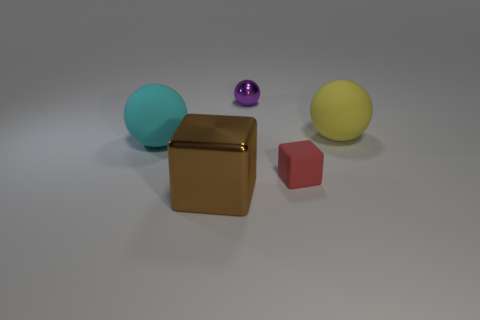Subtract all small purple spheres. How many spheres are left? 2 Add 2 small red matte objects. How many objects exist? 7 Subtract all yellow balls. How many balls are left? 2 Subtract all spheres. How many objects are left? 2 Subtract all yellow blocks. Subtract all red cylinders. How many blocks are left? 2 Subtract all shiny spheres. Subtract all big objects. How many objects are left? 1 Add 3 small shiny things. How many small shiny things are left? 4 Add 1 purple rubber balls. How many purple rubber balls exist? 1 Subtract 1 cyan balls. How many objects are left? 4 Subtract 1 cubes. How many cubes are left? 1 